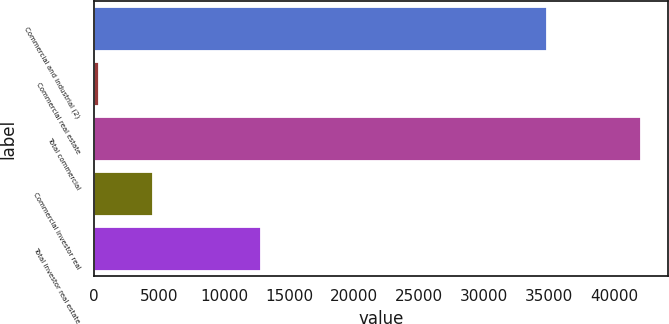Convert chart. <chart><loc_0><loc_0><loc_500><loc_500><bar_chart><fcel>Commercial and industrial (2)<fcel>Commercial real estate<fcel>Total commercial<fcel>Commercial investor real<fcel>Total investor real estate<nl><fcel>34849<fcel>334<fcel>42050<fcel>4505.6<fcel>12848.8<nl></chart> 